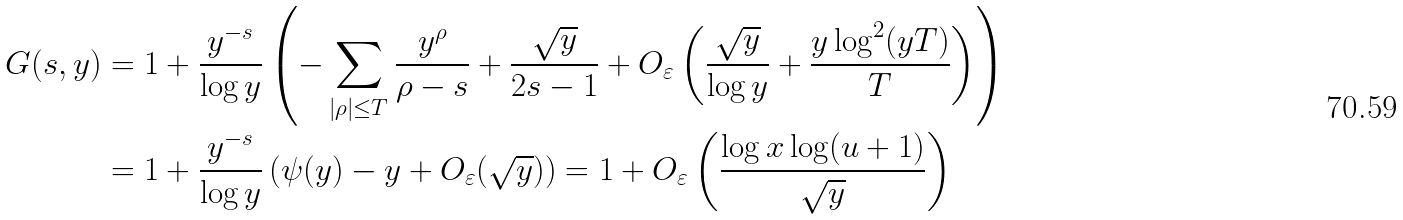<formula> <loc_0><loc_0><loc_500><loc_500>G ( s , y ) & = 1 + \frac { y ^ { - s } } { \log y } \left ( - \sum _ { | \rho | \leq T } \frac { y ^ { \rho } } { \rho - s } + \frac { \sqrt { y } } { 2 s - 1 } + O _ { \varepsilon } \left ( \frac { \sqrt { y } } { \log y } + \frac { y \log ^ { 2 } ( y T ) } { T } \right ) \right ) \\ & = 1 + \frac { y ^ { - s } } { \log y } \left ( \psi ( y ) - y + O _ { \varepsilon } ( \sqrt { y } ) \right ) = 1 + O _ { \varepsilon } \left ( \frac { \log x \log ( u + 1 ) } { \sqrt { y } } \right )</formula> 